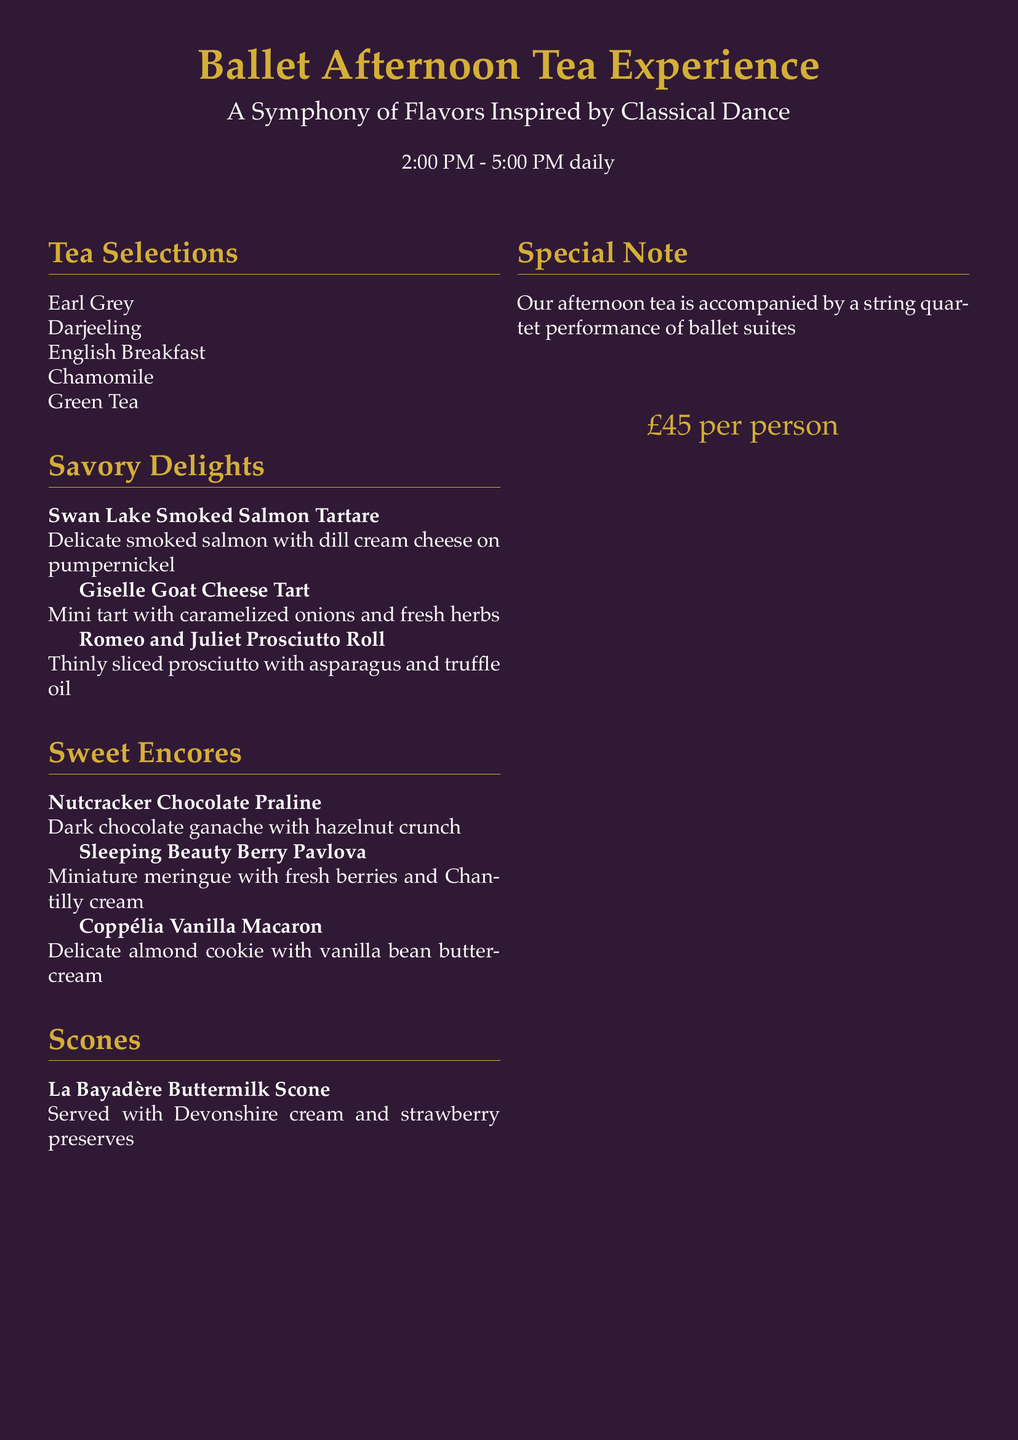What time does the afternoon tea event start? The afternoon tea event is scheduled from 2:00 PM to 5:00 PM daily, indicating the start time is 2:00 PM.
Answer: 2:00 PM What is the price per person for the afternoon tea experience? The price listed for the afternoon tea experience is £45 per person, which is explicitly stated in the document.
Answer: £45 Which savory item features goat cheese? The savory item that includes goat cheese is the "Giselle Goat Cheese Tart," as mentioned in the menu section.
Answer: Giselle Goat Cheese Tart What type of pastry is associated with "Sleeping Beauty"? The dessert related to "Sleeping Beauty" is the "Berry Pavlova," according to the sweet encores section of the document.
Answer: Berry Pavlova What accompaniment is included with the La Bayadère buttermilk scone? The La Bayadère buttermilk scone is served with Devonshire cream and strawberry preserves, as outlined in the scone section.
Answer: Devonshire cream and strawberry preserves How many types of tea selections are there? The document lists five different tea selections, as detailed in the tea selections section.
Answer: 5 What performance accompanies the afternoon tea? The afternoon tea is accompanied by a string quartet performance of ballet suites, which is specified in the special note section.
Answer: A string quartet performance of ballet suites Which savory option includes truffle oil? The savory option that contains truffle oil is the "Romeo and Juliet Prosciutto Roll," as described in the menu.
Answer: Romeo and Juliet Prosciutto Roll What color is the background of the document? The background of the document is dark purple, as indicated on the first page of the menu.
Answer: Dark purple 